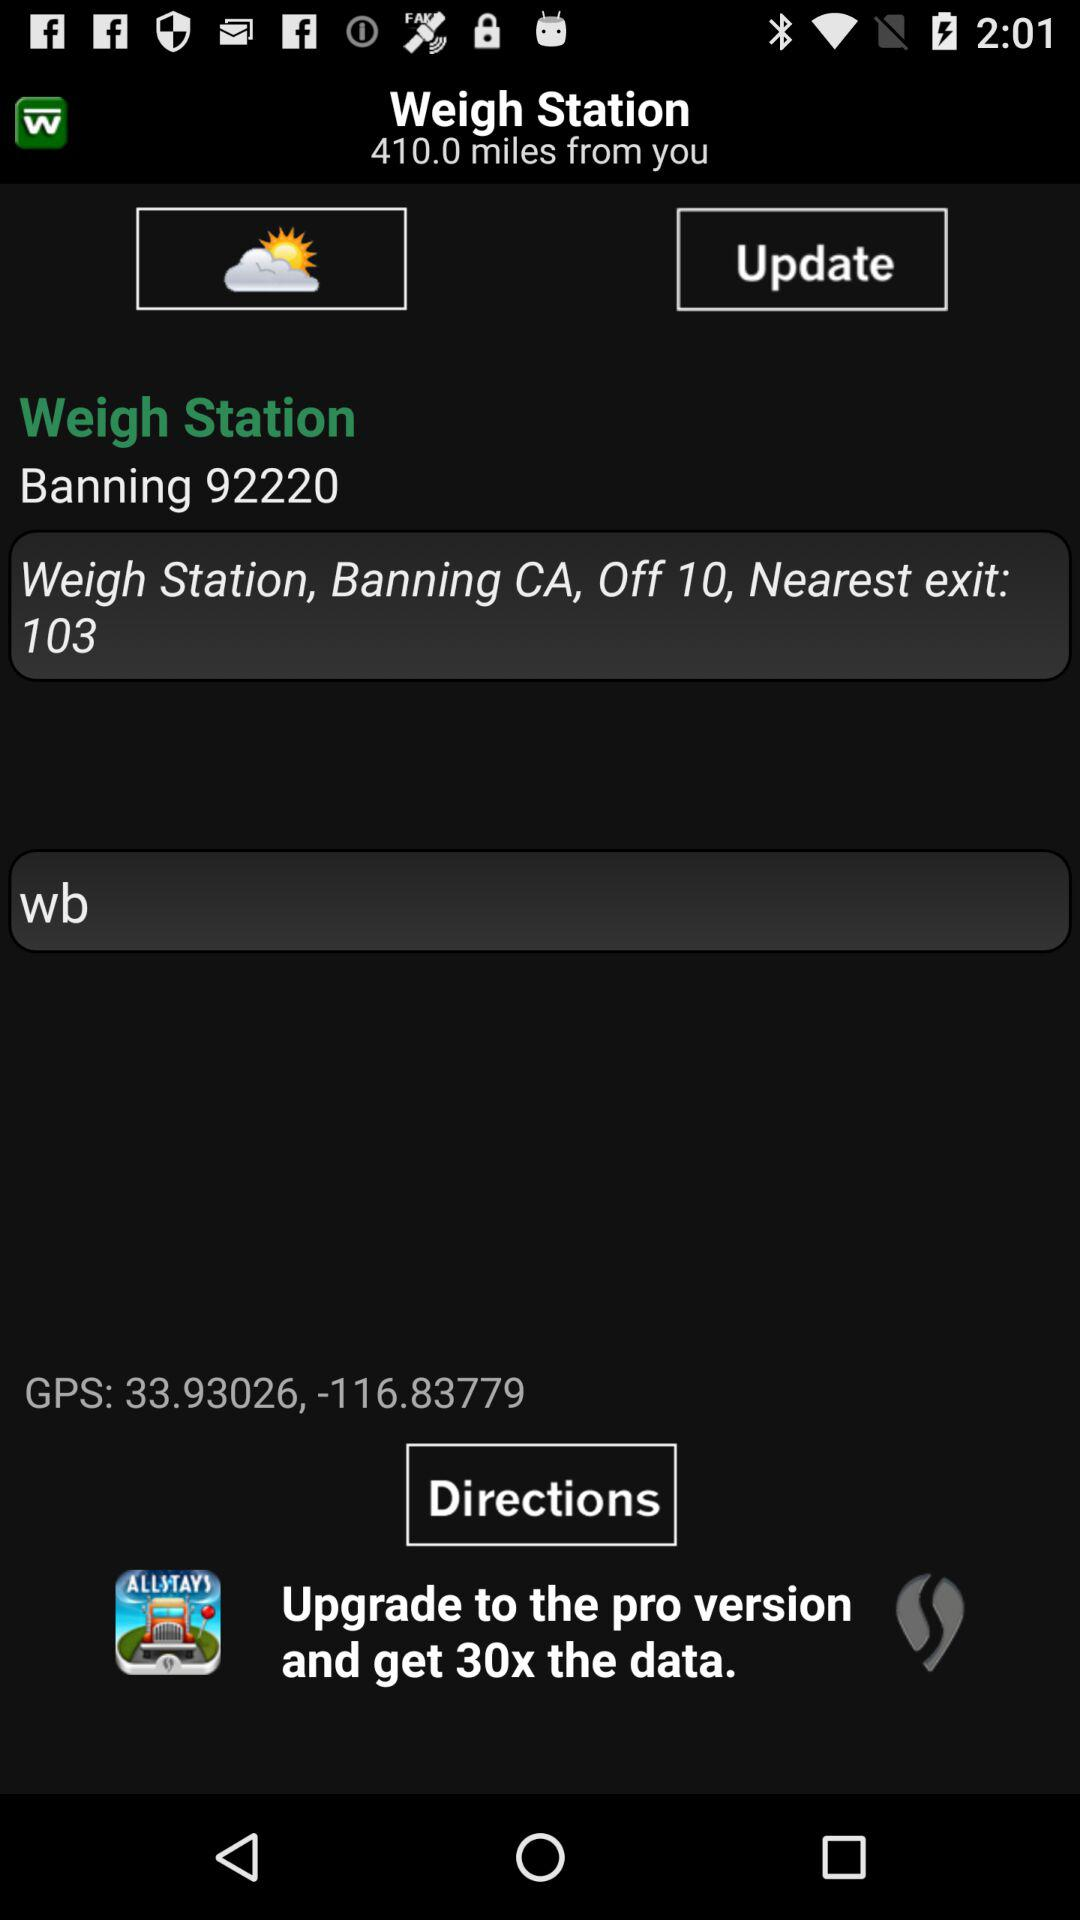How far is the Weigh station from you? The Weigh station is 410.0 miles. 